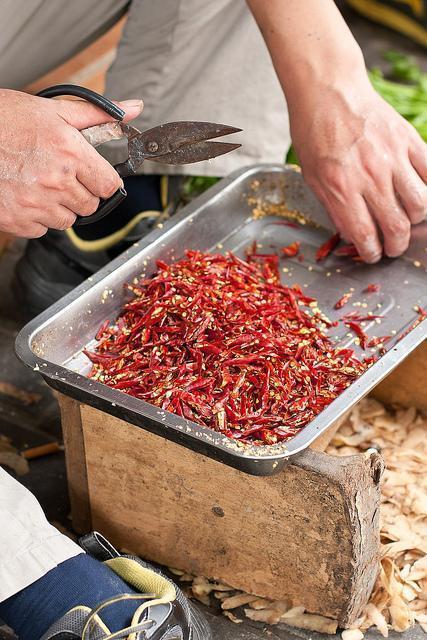Which is widely used in many cuisines as a spice to add pungent 'heat' to dishes?
Choose the right answer and clarify with the format: 'Answer: answer
Rationale: rationale.'
Options: Cucumber, capsicum, melon, chilies. Answer: chilies.
Rationale: They are spicy and you can see the actual vegetable and it's seeds being cut. 